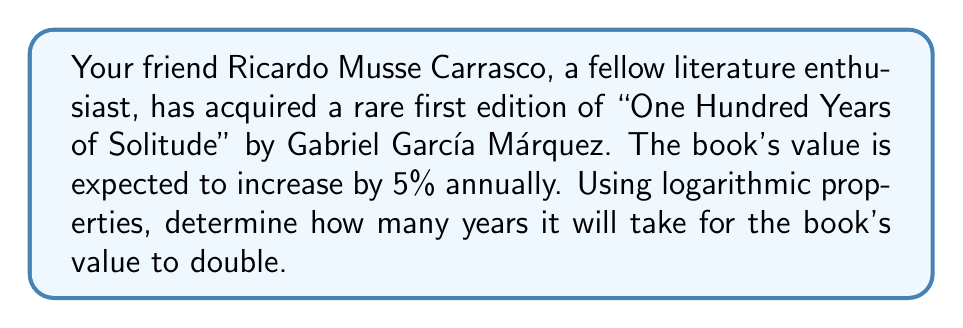What is the answer to this math problem? Let's approach this step-by-step using logarithmic properties:

1) Let $P$ be the initial value of the book and $t$ be the time in years.
   The future value after $t$ years will be $P(1.05)^t$.

2) For the value to double, we need:
   $P(1.05)^t = 2P$

3) Dividing both sides by $P$:
   $(1.05)^t = 2$

4) Taking the natural logarithm of both sides:
   $t \ln(1.05) = \ln(2)$

5) Solving for $t$:
   $t = \frac{\ln(2)}{\ln(1.05)}$

6) Using the change of base formula:
   $t = \frac{\log_2(2)}{\log_2(1.05)} = \frac{1}{\log_2(1.05)}$

7) Calculate this value:
   $t \approx 14.2067$

8) Since we're dealing with whole years, we round up to the next integer.
Answer: 15 years 